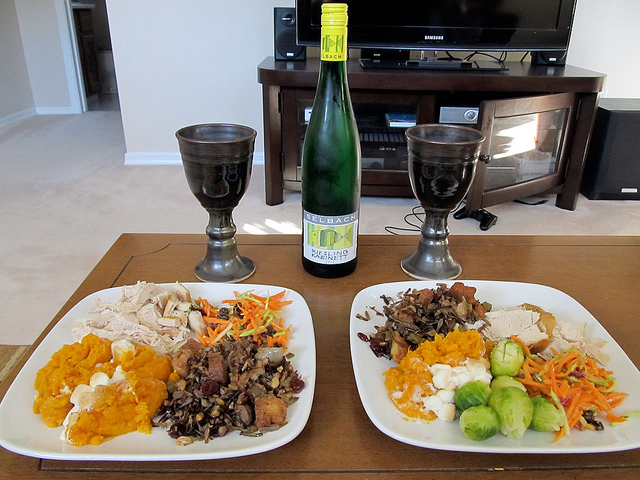Read and extract the text from this image. TEACH 